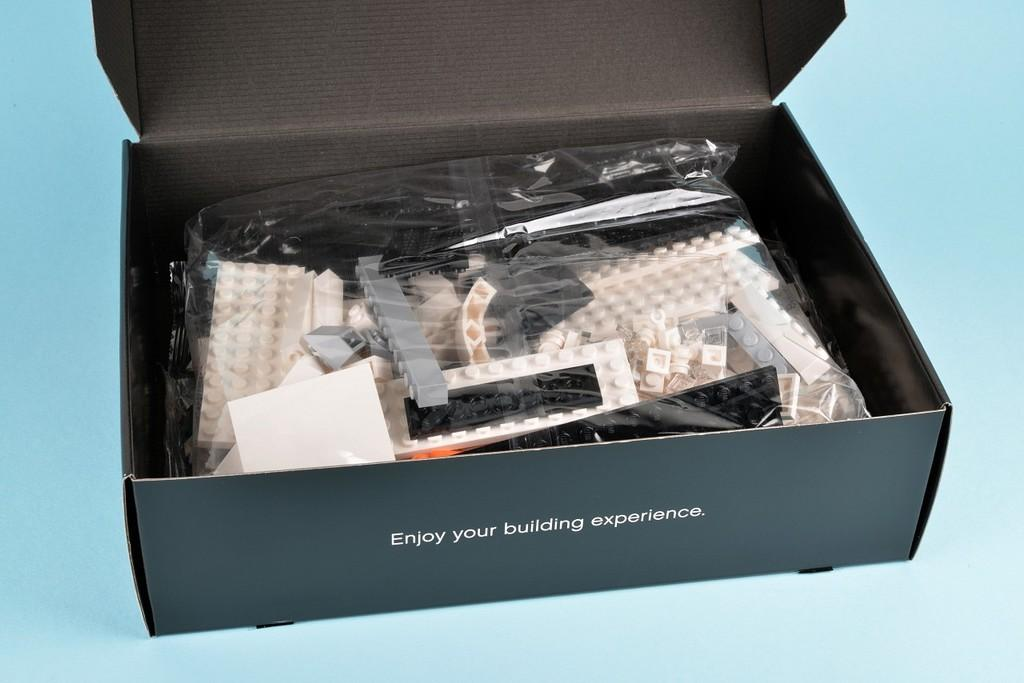Provide a one-sentence caption for the provided image. A box of legos suggests to Enjoy your building experience. 